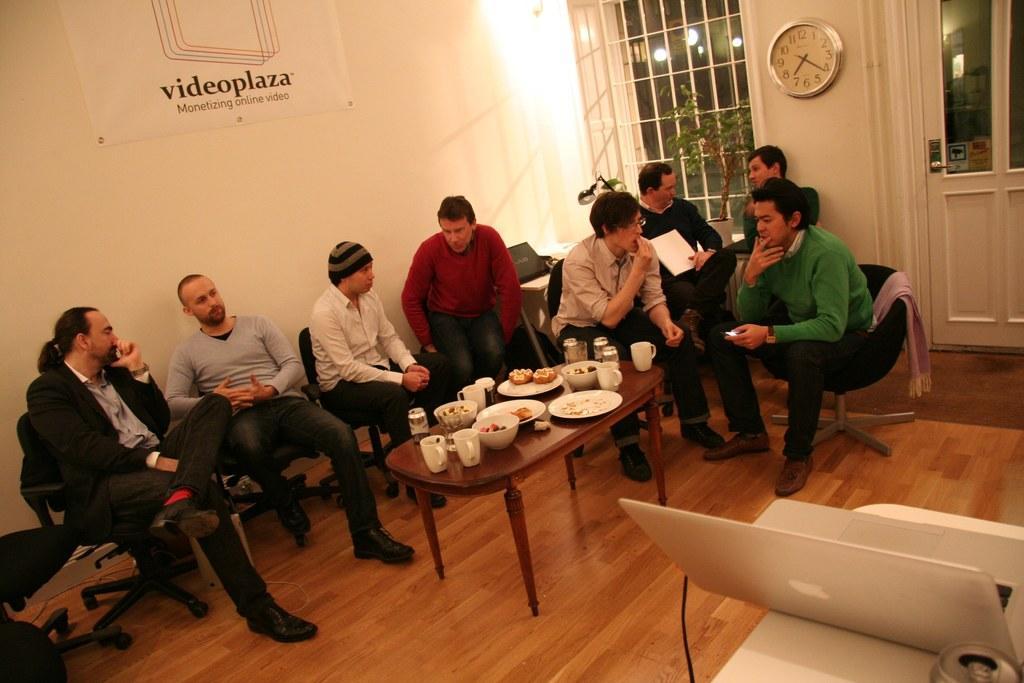Please provide a concise description of this image. It is a work place, there is a table and lot of food items on the table around the table there are group of people sitting and discussing, they are sitting in the black chair, in the background there is a white color wall on the wall there is a poster to the right side there is a window beside that there is a clock, beside that there is a door. 